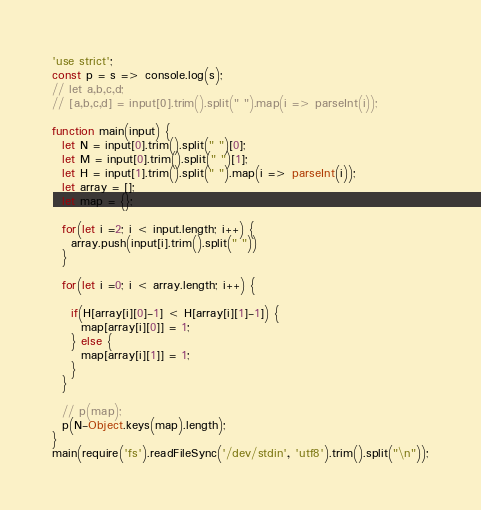Convert code to text. <code><loc_0><loc_0><loc_500><loc_500><_JavaScript_>'use strict';
const p = s => console.log(s);
// let a,b,c,d;
// [a,b,c,d] = input[0].trim().split(" ").map(i => parseInt(i));

function main(input) {
  let N = input[0].trim().split(" ")[0];
  let M = input[0].trim().split(" ")[1];
  let H = input[1].trim().split(" ").map(i => parseInt(i));
  let array = [];
  let map = {};

  for(let i =2; i < input.length; i++) {
    array.push(input[i].trim().split(" "))
  }

  for(let i =0; i < array.length; i++) {

    if(H[array[i][0]-1] < H[array[i][1]-1]) {
      map[array[i][0]] = 1;
    } else {
      map[array[i][1]] = 1;
    }
  }

  // p(map);
  p(N-Object.keys(map).length);
}
main(require('fs').readFileSync('/dev/stdin', 'utf8').trim().split("\n"));
</code> 